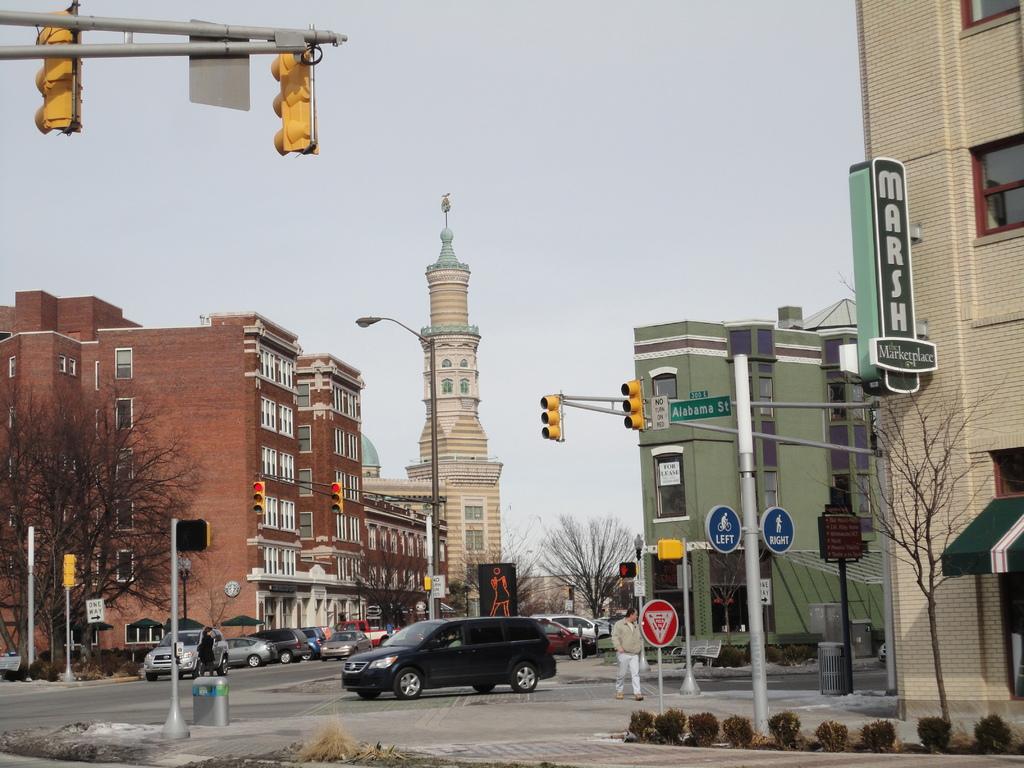What street is this one?
Your answer should be very brief. Alabama. What is the name of the marketplace?
Offer a terse response. Marsh. 